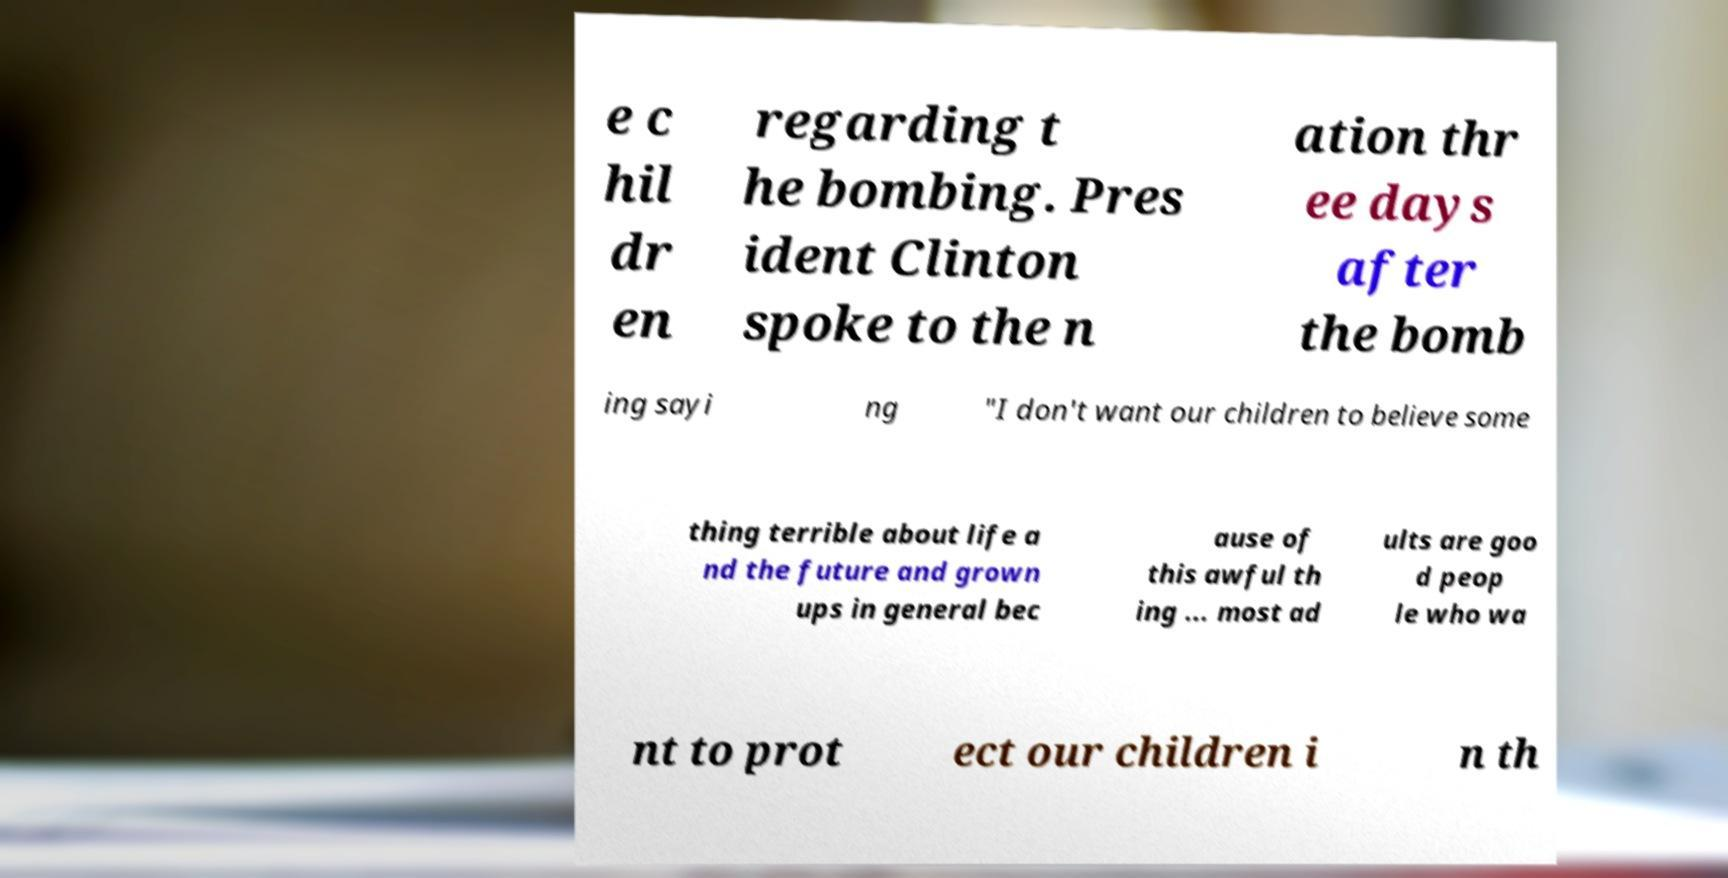There's text embedded in this image that I need extracted. Can you transcribe it verbatim? e c hil dr en regarding t he bombing. Pres ident Clinton spoke to the n ation thr ee days after the bomb ing sayi ng "I don't want our children to believe some thing terrible about life a nd the future and grown ups in general bec ause of this awful th ing ... most ad ults are goo d peop le who wa nt to prot ect our children i n th 